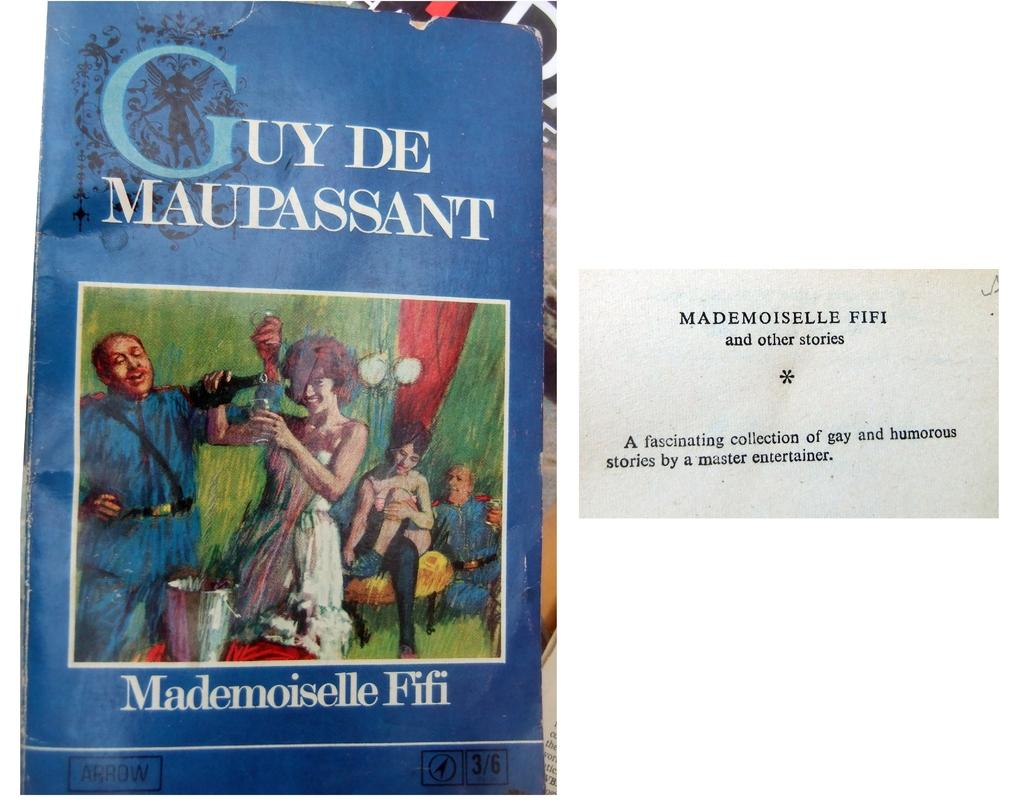<image>
Offer a succinct explanation of the picture presented. The book Mademoiselle Fifi" by Guy De Maupassant. 